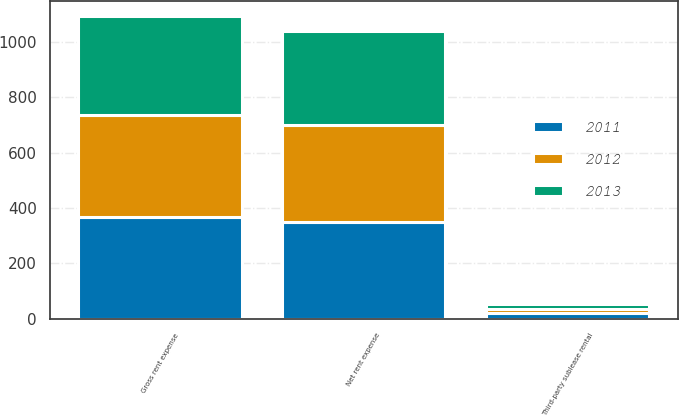Convert chart to OTSL. <chart><loc_0><loc_0><loc_500><loc_500><stacked_bar_chart><ecel><fcel>Gross rent expense<fcel>Third-party sublease rental<fcel>Net rent expense<nl><fcel>2012<fcel>366.1<fcel>16.1<fcel>350<nl><fcel>2013<fcel>358.5<fcel>17.5<fcel>341<nl><fcel>2011<fcel>369.5<fcel>19.4<fcel>350.1<nl></chart> 